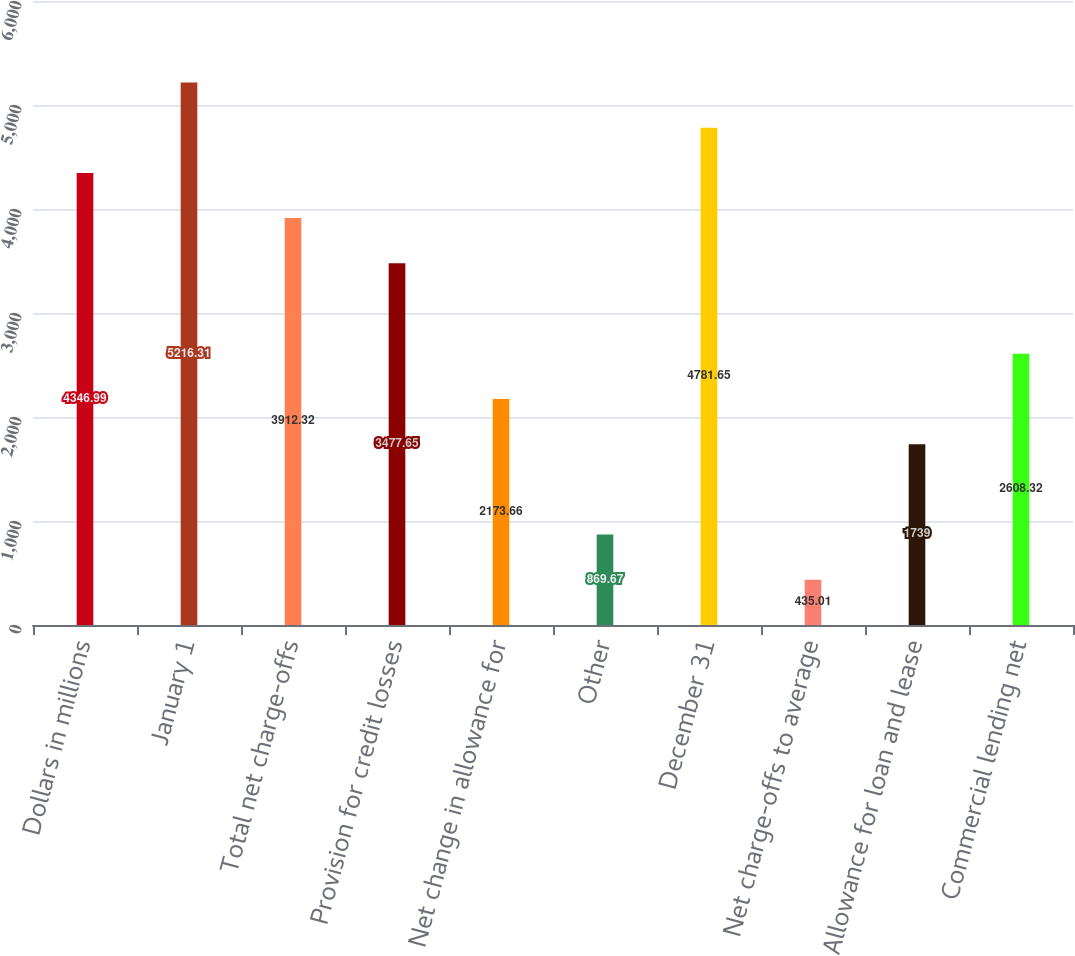<chart> <loc_0><loc_0><loc_500><loc_500><bar_chart><fcel>Dollars in millions<fcel>January 1<fcel>Total net charge-offs<fcel>Provision for credit losses<fcel>Net change in allowance for<fcel>Other<fcel>December 31<fcel>Net charge-offs to average<fcel>Allowance for loan and lease<fcel>Commercial lending net<nl><fcel>4346.99<fcel>5216.31<fcel>3912.32<fcel>3477.65<fcel>2173.66<fcel>869.67<fcel>4781.65<fcel>435.01<fcel>1739<fcel>2608.32<nl></chart> 